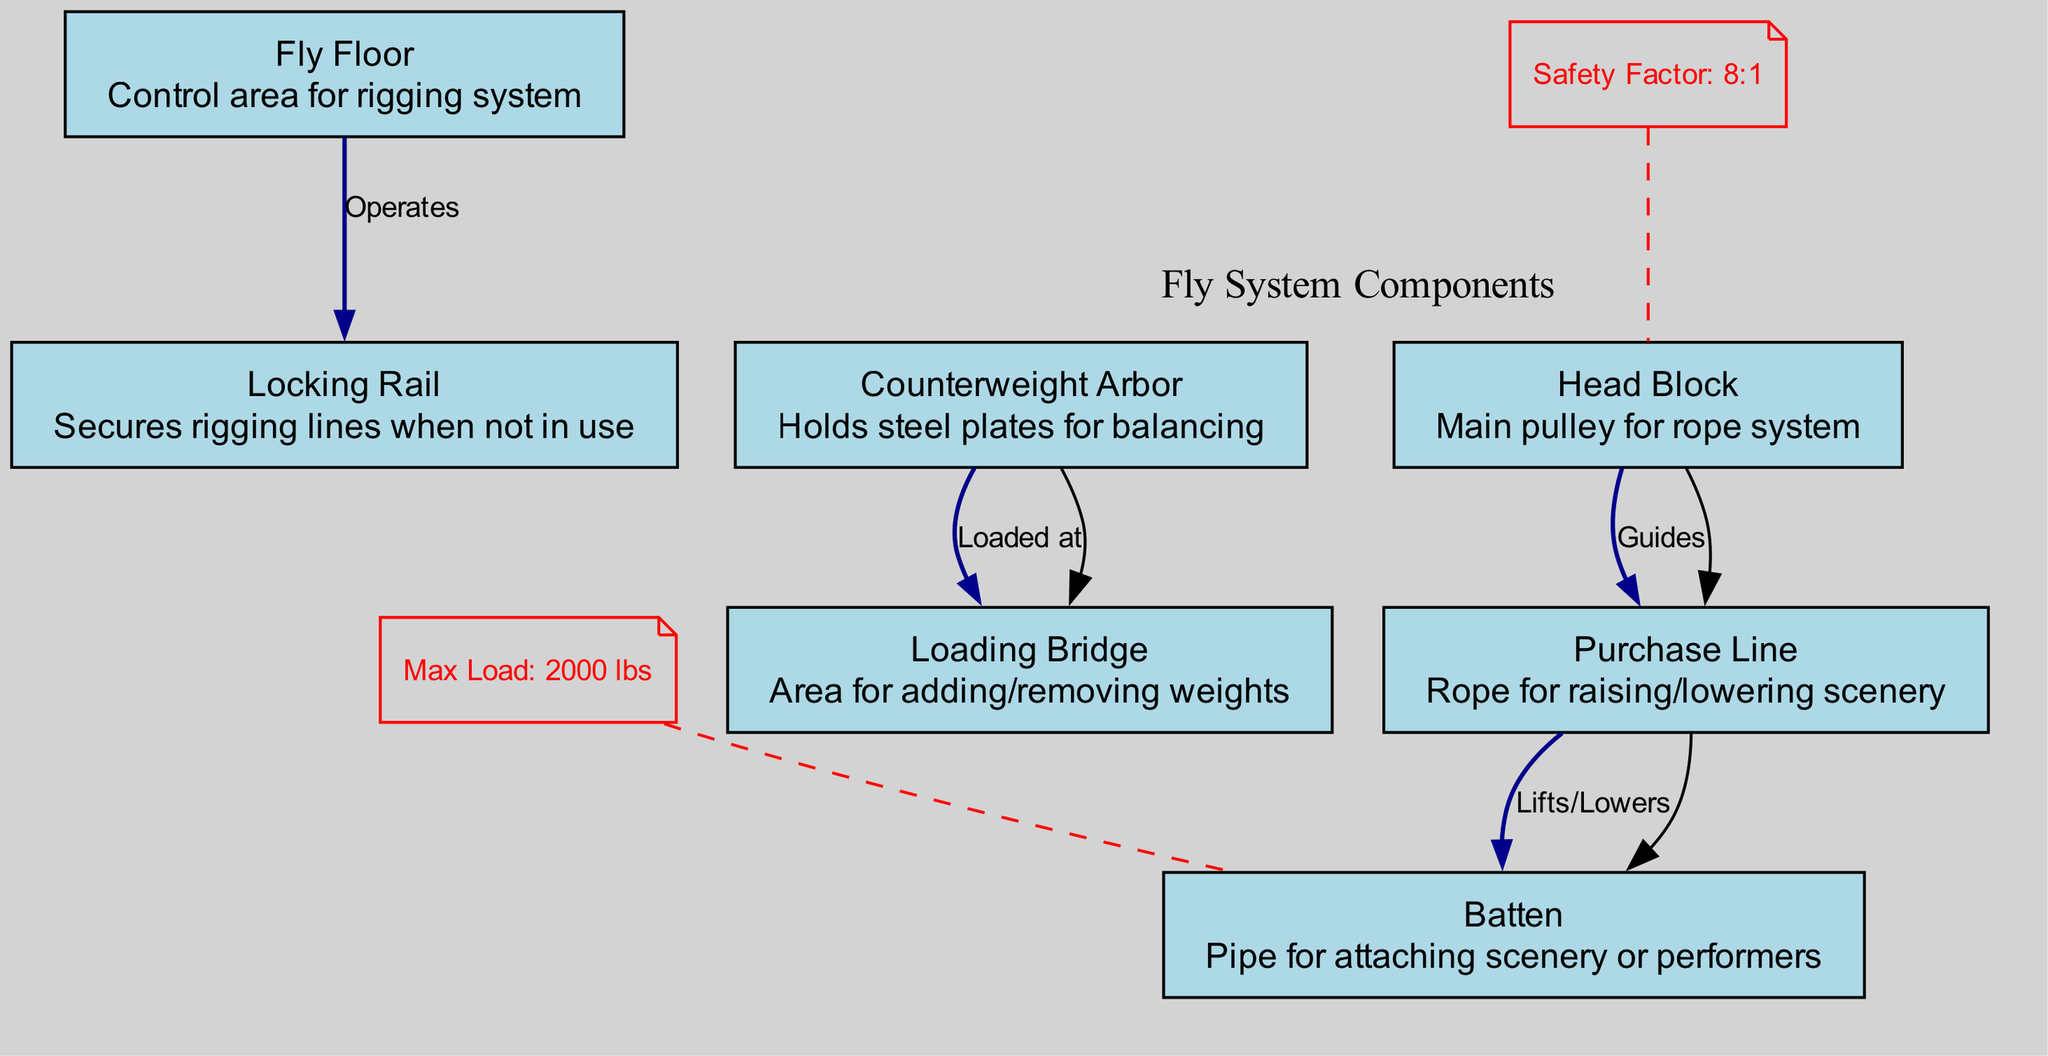What is the maximum load listed for the batten? The diagram indicates a maximum load of 2000 lbs, which is specifically annotated and connected to the batten node.
Answer: 2000 lbs What component holds steel plates for balancing? The counterweight arbor is directly described in the diagram as holding steel plates for balancing, making it the relevant component.
Answer: Counterweight Arbor How many nodes are present in the diagram? Counting the nodes listed in the diagram, there are a total of 7 unique components present.
Answer: 7 Which node operates the locking rail? The fly floor is the one that operates the locking rail, as indicated by the direct edge connection labeled "Operates."
Answer: Fly Floor What is the safety factor associated with the head block? The safety factor is noted as 8:1, which is specifically annotated and connected to the head block node.
Answer: 8:1 How does the purchase line interact with the scenery? The purchase line is responsible for lifting and lowering the scenery, as indicated by its connection to the batten node with the label "Lifts/Lowers."
Answer: Lifts/Lowers Which component is used for raising or lowering scenery? The purchase line is designated for raising or lowering scenery; it is indicated in the diagram by the node description.
Answer: Purchase Line What is the purpose of the loading bridge in relation to the counterweight arbor? The loading bridge is the area where weights are added or removed, and it is directly loaded at the counterweight arbor, as shown by the edge connection "Loaded at."
Answer: Area for adding/removing weights What kind of edge connects the locking rail to the fly floor? The edge connecting the locking rail to the fly floor is labeled "Operates," showing the functional relationship between these two components.
Answer: Operates 